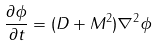<formula> <loc_0><loc_0><loc_500><loc_500>\frac { \partial \phi } { \partial t } = ( D + M ^ { 2 } ) { \nabla } ^ { 2 } \phi</formula> 